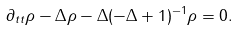<formula> <loc_0><loc_0><loc_500><loc_500>\partial _ { t t } \rho - \Delta \rho - \Delta ( - \Delta + 1 ) ^ { - 1 } \rho = 0 .</formula> 